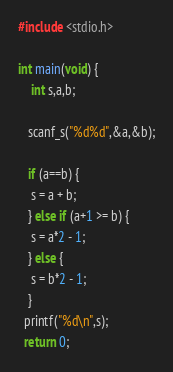Convert code to text. <code><loc_0><loc_0><loc_500><loc_500><_C_>#include <stdio.h>
 
int main(void) {
	int s,a,b;
    
   scanf_s("%d%d",&a,&b);
   
   if (a==b) {
    s = a + b;
   } else if (a+1 >= b) {
   	s = a*2 - 1;
   } else {
   	s = b*2 - 1;
   }
  printf("%d\n",s);
  return 0;
</code> 